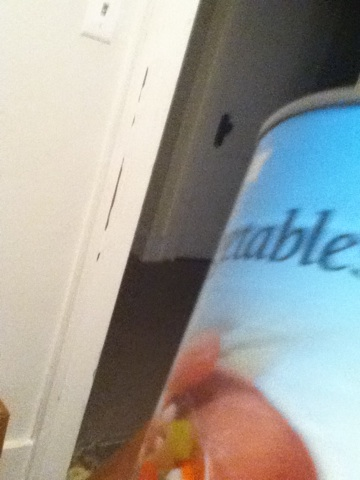What is a realistic daily scenario involving this can of vegetables? A busy working parent comes home after a long day at work. With little time to prepare a nutritious meal from scratch, they open the pantry and spot this can of mixed vegetables. In a matter of minutes, they toss the vegetables into a heated pan with some leftover rice and a splash of soy sauce, creating a quick and healthy vegetable fried rice that the entire family enjoys. Can this can of vegetables be useful in an emergency? Absolutely. In an emergency situation where fresh food is not available, a can of vegetables can be a lifesaver. It's non-perishable and can be stored for long periods, making it a reliable source of nutrients. Whether it's during a natural disaster or a power outage, having canned vegetables on hand can help ensure that you still have access to essential vitamins and minerals. 